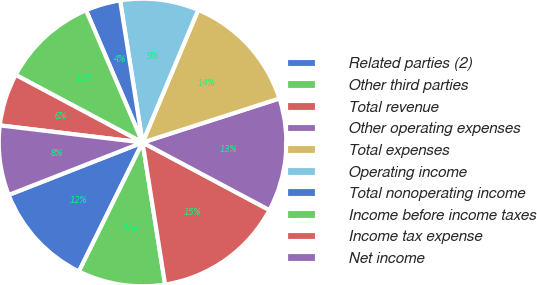Convert chart to OTSL. <chart><loc_0><loc_0><loc_500><loc_500><pie_chart><fcel>Related parties (2)<fcel>Other third parties<fcel>Total revenue<fcel>Other operating expenses<fcel>Total expenses<fcel>Operating income<fcel>Total nonoperating income<fcel>Income before income taxes<fcel>Income tax expense<fcel>Net income<nl><fcel>11.76%<fcel>9.8%<fcel>14.7%<fcel>12.74%<fcel>13.72%<fcel>8.82%<fcel>3.93%<fcel>10.78%<fcel>5.89%<fcel>7.84%<nl></chart> 